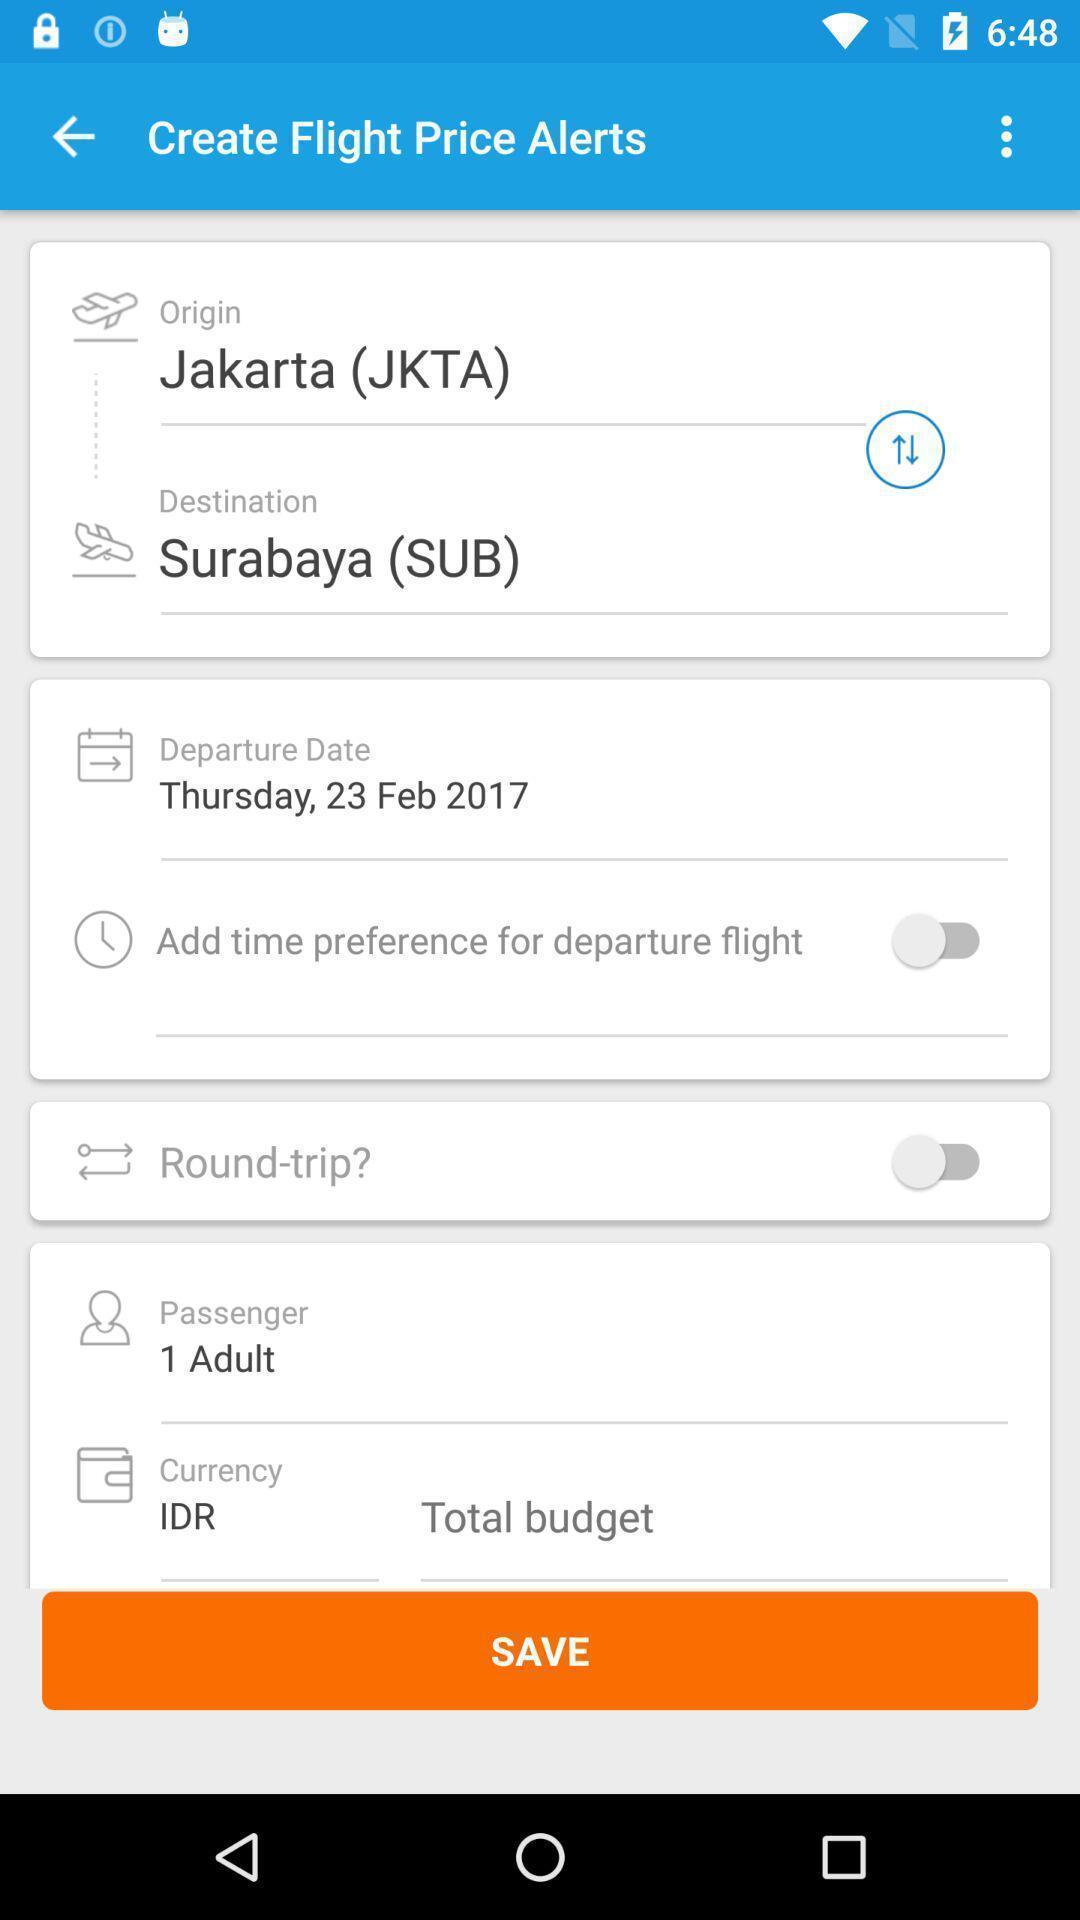Explain what's happening in this screen capture. Page of a flight booking app. 